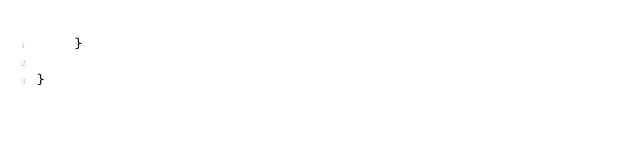Convert code to text. <code><loc_0><loc_0><loc_500><loc_500><_Java_>	}
    
}
</code> 